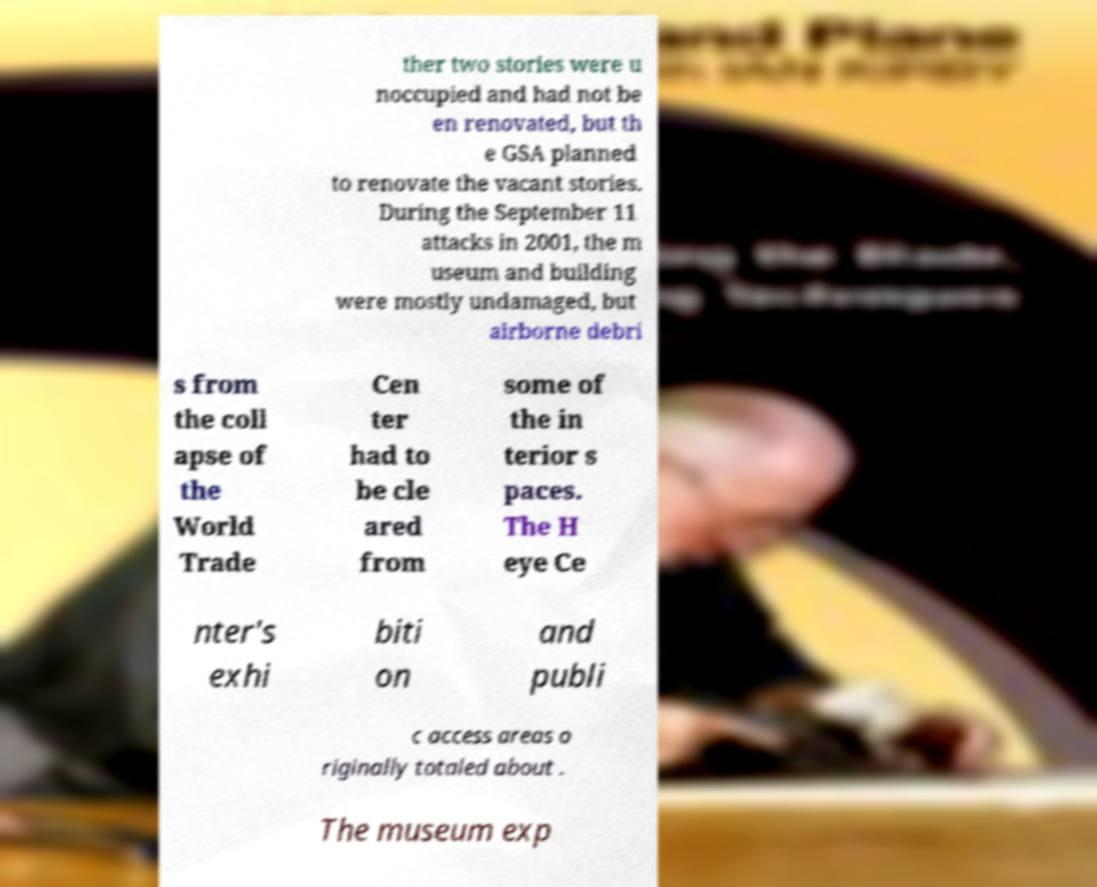Could you assist in decoding the text presented in this image and type it out clearly? ther two stories were u noccupied and had not be en renovated, but th e GSA planned to renovate the vacant stories. During the September 11 attacks in 2001, the m useum and building were mostly undamaged, but airborne debri s from the coll apse of the World Trade Cen ter had to be cle ared from some of the in terior s paces. The H eye Ce nter's exhi biti on and publi c access areas o riginally totaled about . The museum exp 